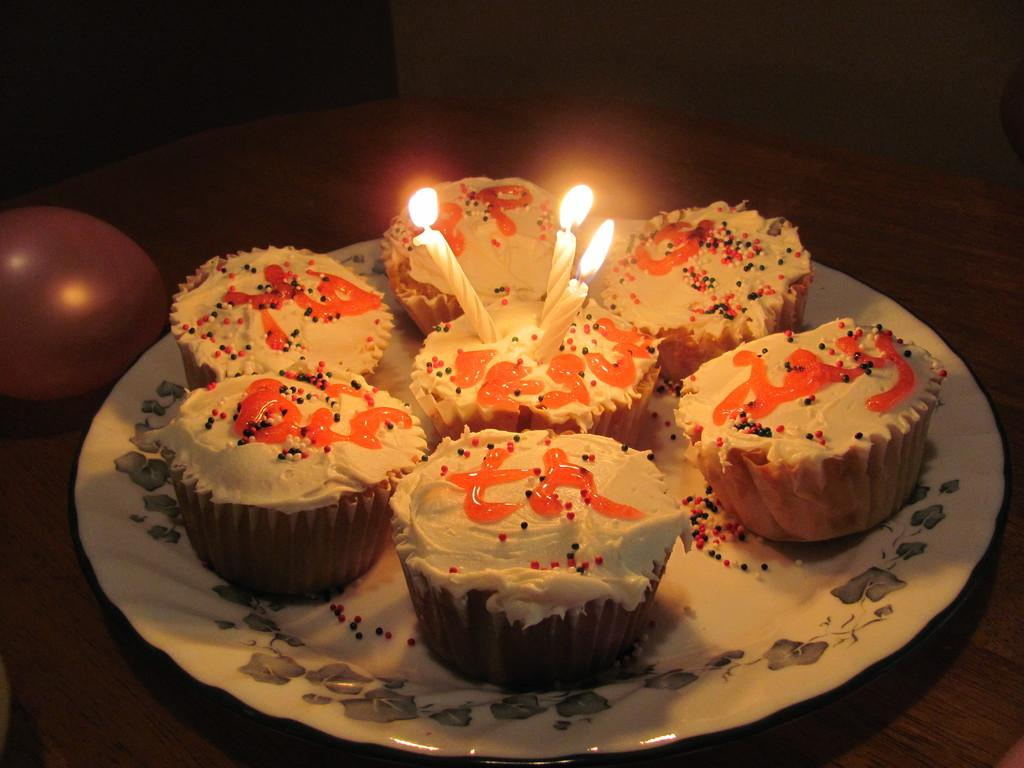What can be seen floating in the image? There is a balloon in the image. What type of food is on the plate in the image? There is a plate with cupcakes in the image. Are there any additional decorations on the plate? Yes, there are candles on the plate in the image. Where are the balloon and plate located in the image? The balloon and plate are on a table in the image. What type of basin is used to hold the alarm in the image? There is no basin or alarm present in the image; it features a balloon, a plate with cupcakes, and candles on a table. 